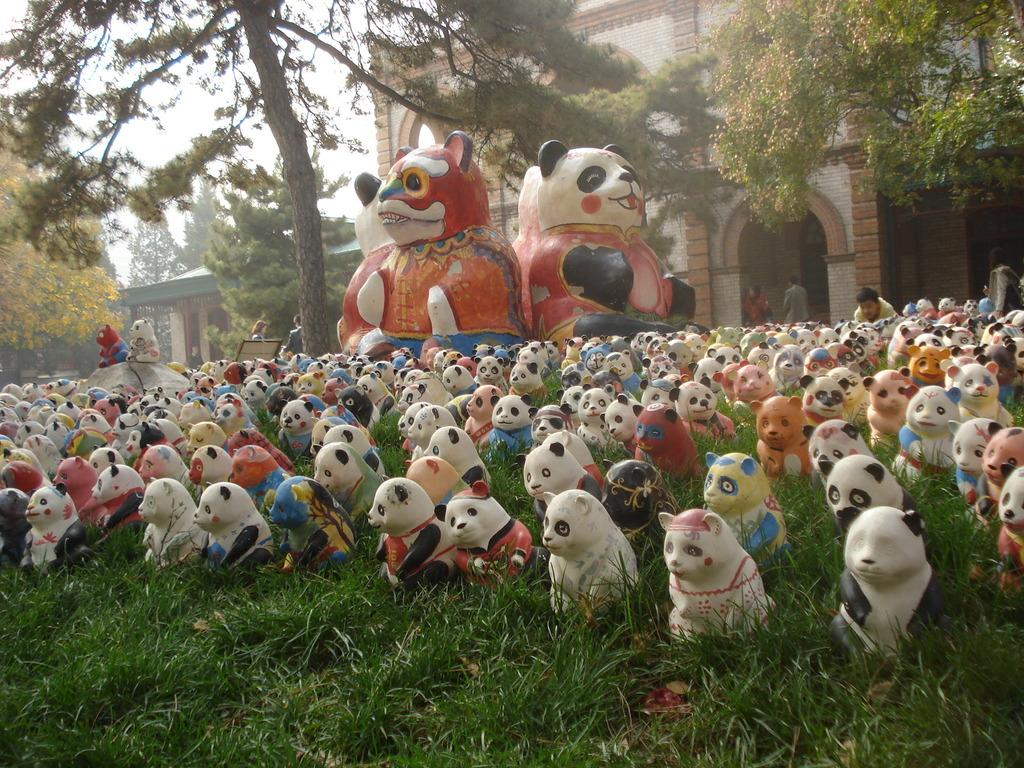What can be found on the grass in the image? There are statues on the grass in the image. What is visible in the background of the image? There are trees, buildings, persons, and the sky visible in the background of the image. What type of mine can be seen in the image? There is no mine present in the image. What is the chance of finding a guitar in the image? There is no guitar present in the image, so it cannot be found. 